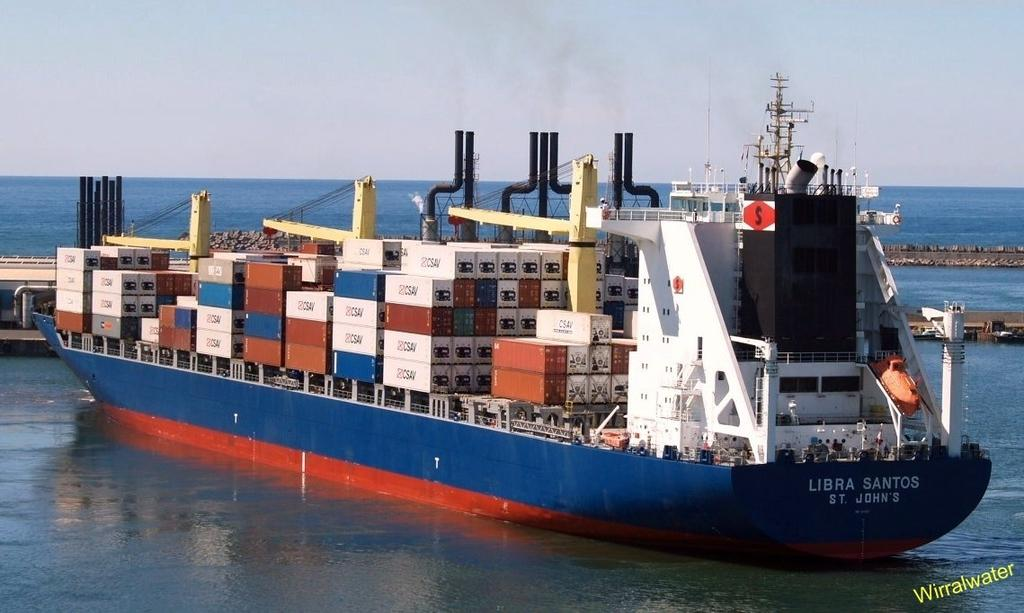What is the main subject of the image? The main subject of the image is a ship. What is the ship doing in the image? The ship is sailing in water. What other structures can be seen in the image? There is a bridge visible in the image. What is visible at the top of the image? The sky is visible at the top of the image. What type of receipt can be seen hanging from the ship's mast in the image? There is no receipt present in the image, and therefore no such item can be observed hanging from the ship's mast. 